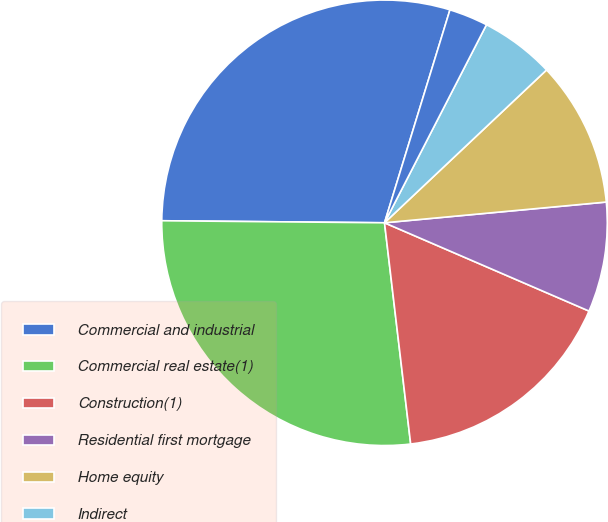Convert chart to OTSL. <chart><loc_0><loc_0><loc_500><loc_500><pie_chart><fcel>Commercial and industrial<fcel>Commercial real estate(1)<fcel>Construction(1)<fcel>Residential first mortgage<fcel>Home equity<fcel>Indirect<fcel>Other consumer<nl><fcel>29.6%<fcel>27.02%<fcel>16.64%<fcel>7.97%<fcel>10.55%<fcel>5.4%<fcel>2.82%<nl></chart> 